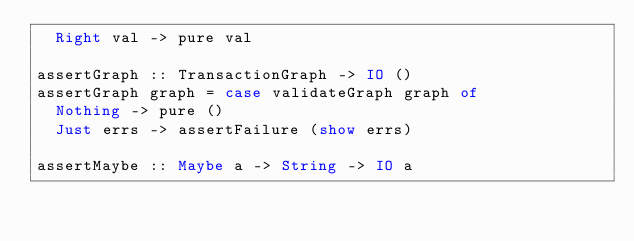<code> <loc_0><loc_0><loc_500><loc_500><_Haskell_>  Right val -> pure val
  
assertGraph :: TransactionGraph -> IO ()  
assertGraph graph = case validateGraph graph of
  Nothing -> pure ()
  Just errs -> assertFailure (show errs)
  
assertMaybe :: Maybe a -> String -> IO a</code> 